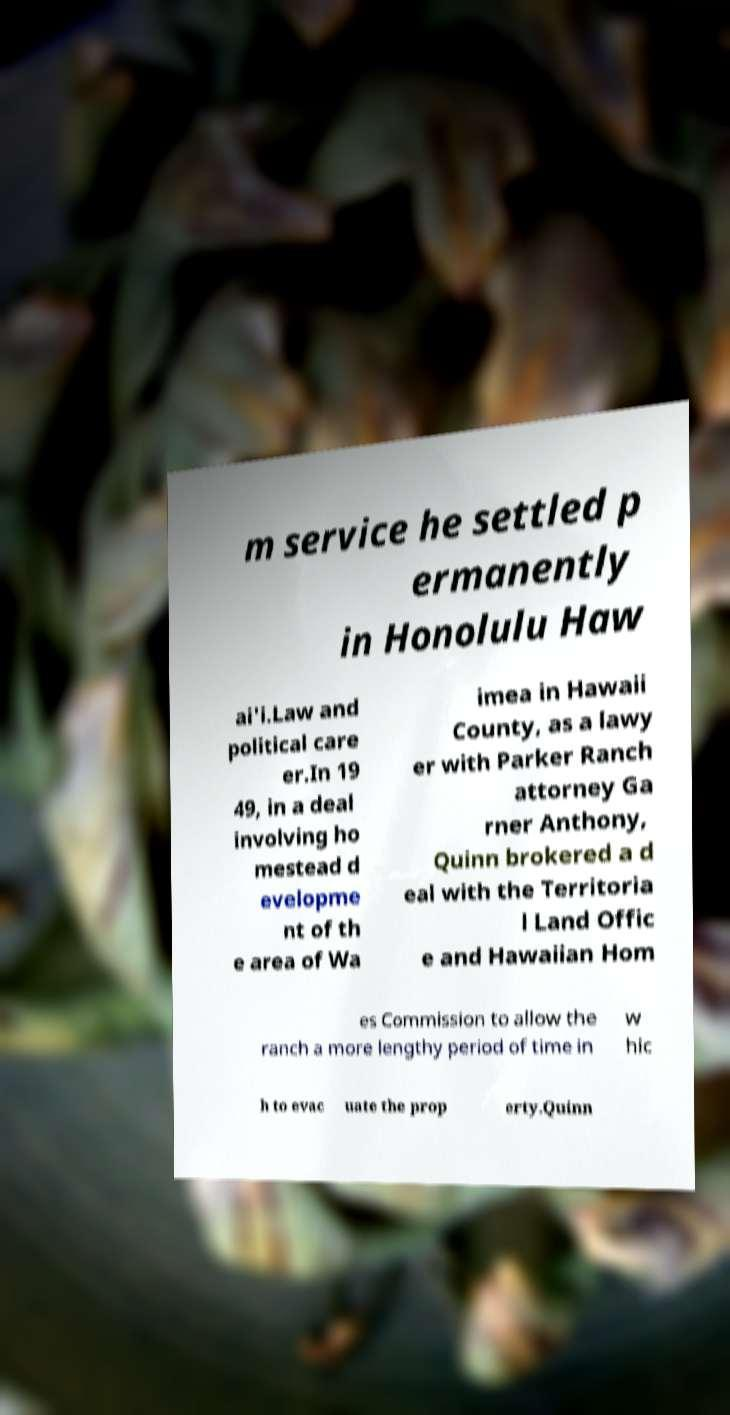Could you assist in decoding the text presented in this image and type it out clearly? m service he settled p ermanently in Honolulu Haw ai'i.Law and political care er.In 19 49, in a deal involving ho mestead d evelopme nt of th e area of Wa imea in Hawaii County, as a lawy er with Parker Ranch attorney Ga rner Anthony, Quinn brokered a d eal with the Territoria l Land Offic e and Hawaiian Hom es Commission to allow the ranch a more lengthy period of time in w hic h to evac uate the prop erty.Quinn 